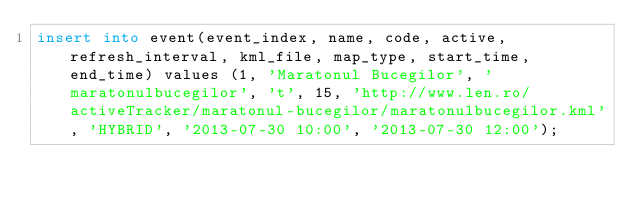<code> <loc_0><loc_0><loc_500><loc_500><_SQL_>insert into event(event_index, name, code, active, refresh_interval, kml_file, map_type, start_time, end_time) values (1, 'Maratonul Bucegilor', 'maratonulbucegilor', 't', 15, 'http://www.len.ro/activeTracker/maratonul-bucegilor/maratonulbucegilor.kml', 'HYBRID', '2013-07-30 10:00', '2013-07-30 12:00');

</code> 